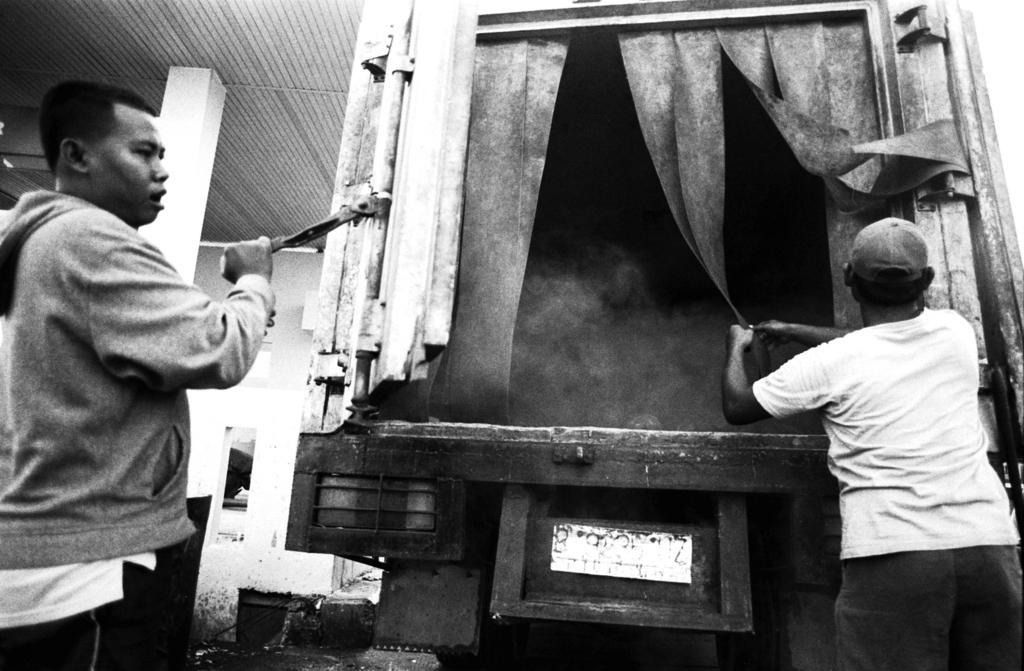How would you summarize this image in a sentence or two? This is a black and white image, in this image there are two persons and there is a van. 